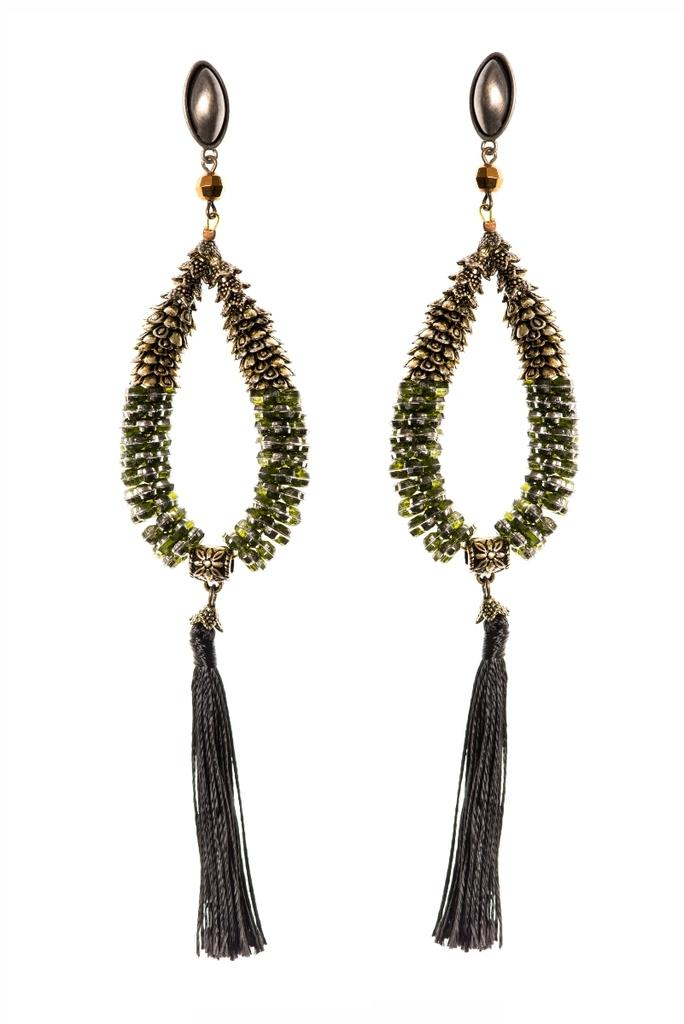What type of accessory is present in the image? There is a pair of earrings in the image. Can you describe the earrings in more detail? Unfortunately, the image does not provide enough detail to describe the earrings further. What type of flame can be seen coming from the earrings in the image? There is no flame present in the image; it features a pair of earrings. What type of string is attached to the earrings in the image? There is no string attached to the earrings in the image; it only shows the earrings themselves. 